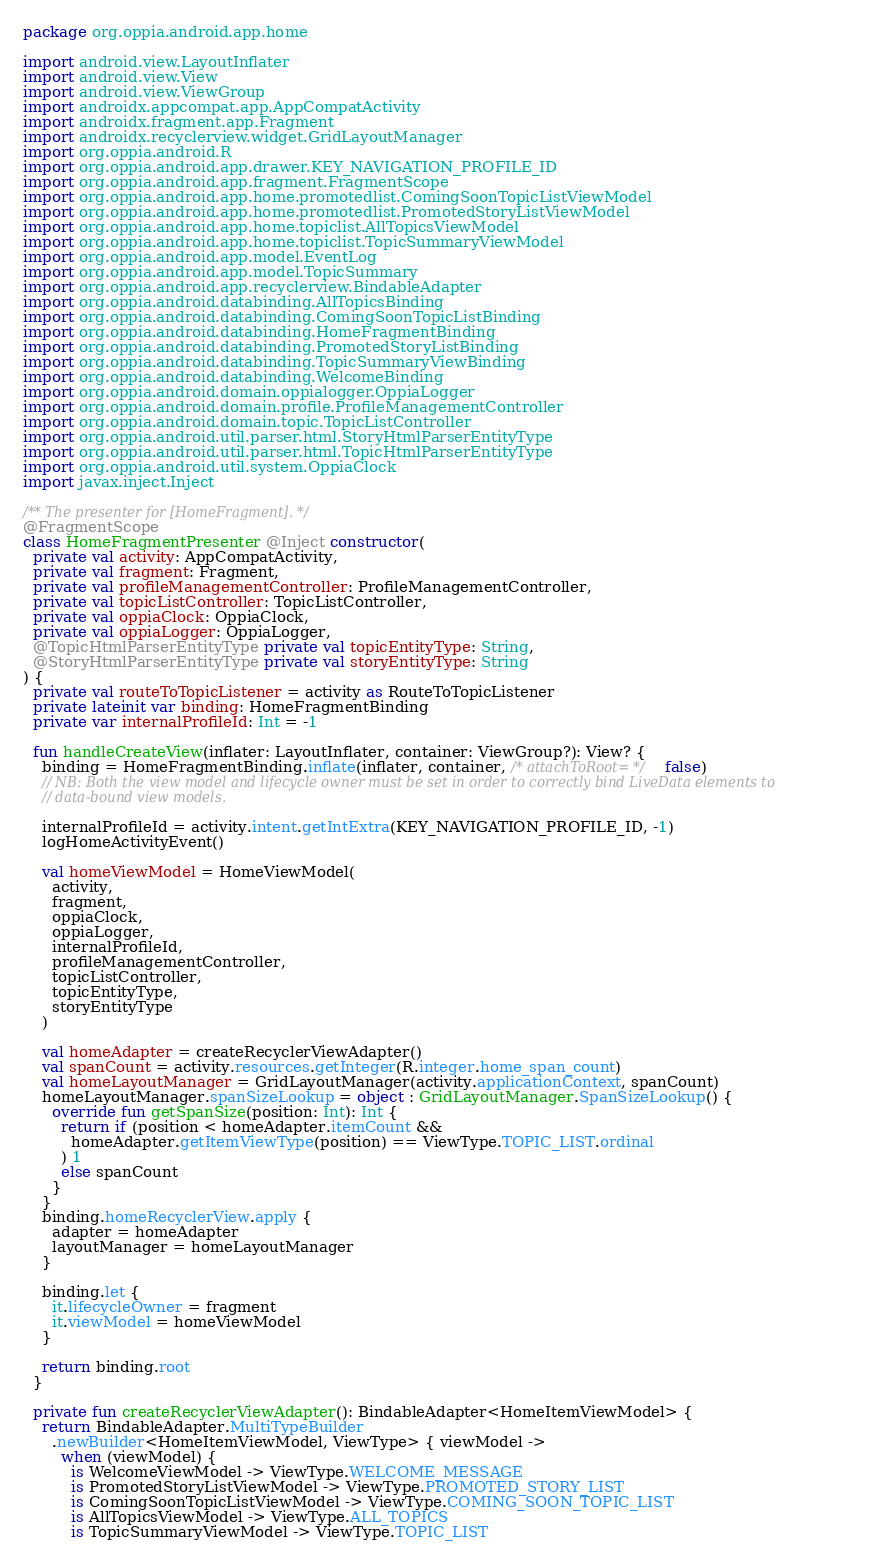Convert code to text. <code><loc_0><loc_0><loc_500><loc_500><_Kotlin_>package org.oppia.android.app.home

import android.view.LayoutInflater
import android.view.View
import android.view.ViewGroup
import androidx.appcompat.app.AppCompatActivity
import androidx.fragment.app.Fragment
import androidx.recyclerview.widget.GridLayoutManager
import org.oppia.android.R
import org.oppia.android.app.drawer.KEY_NAVIGATION_PROFILE_ID
import org.oppia.android.app.fragment.FragmentScope
import org.oppia.android.app.home.promotedlist.ComingSoonTopicListViewModel
import org.oppia.android.app.home.promotedlist.PromotedStoryListViewModel
import org.oppia.android.app.home.topiclist.AllTopicsViewModel
import org.oppia.android.app.home.topiclist.TopicSummaryViewModel
import org.oppia.android.app.model.EventLog
import org.oppia.android.app.model.TopicSummary
import org.oppia.android.app.recyclerview.BindableAdapter
import org.oppia.android.databinding.AllTopicsBinding
import org.oppia.android.databinding.ComingSoonTopicListBinding
import org.oppia.android.databinding.HomeFragmentBinding
import org.oppia.android.databinding.PromotedStoryListBinding
import org.oppia.android.databinding.TopicSummaryViewBinding
import org.oppia.android.databinding.WelcomeBinding
import org.oppia.android.domain.oppialogger.OppiaLogger
import org.oppia.android.domain.profile.ProfileManagementController
import org.oppia.android.domain.topic.TopicListController
import org.oppia.android.util.parser.html.StoryHtmlParserEntityType
import org.oppia.android.util.parser.html.TopicHtmlParserEntityType
import org.oppia.android.util.system.OppiaClock
import javax.inject.Inject

/** The presenter for [HomeFragment]. */
@FragmentScope
class HomeFragmentPresenter @Inject constructor(
  private val activity: AppCompatActivity,
  private val fragment: Fragment,
  private val profileManagementController: ProfileManagementController,
  private val topicListController: TopicListController,
  private val oppiaClock: OppiaClock,
  private val oppiaLogger: OppiaLogger,
  @TopicHtmlParserEntityType private val topicEntityType: String,
  @StoryHtmlParserEntityType private val storyEntityType: String
) {
  private val routeToTopicListener = activity as RouteToTopicListener
  private lateinit var binding: HomeFragmentBinding
  private var internalProfileId: Int = -1

  fun handleCreateView(inflater: LayoutInflater, container: ViewGroup?): View? {
    binding = HomeFragmentBinding.inflate(inflater, container, /* attachToRoot= */ false)
    // NB: Both the view model and lifecycle owner must be set in order to correctly bind LiveData elements to
    // data-bound view models.

    internalProfileId = activity.intent.getIntExtra(KEY_NAVIGATION_PROFILE_ID, -1)
    logHomeActivityEvent()

    val homeViewModel = HomeViewModel(
      activity,
      fragment,
      oppiaClock,
      oppiaLogger,
      internalProfileId,
      profileManagementController,
      topicListController,
      topicEntityType,
      storyEntityType
    )

    val homeAdapter = createRecyclerViewAdapter()
    val spanCount = activity.resources.getInteger(R.integer.home_span_count)
    val homeLayoutManager = GridLayoutManager(activity.applicationContext, spanCount)
    homeLayoutManager.spanSizeLookup = object : GridLayoutManager.SpanSizeLookup() {
      override fun getSpanSize(position: Int): Int {
        return if (position < homeAdapter.itemCount &&
          homeAdapter.getItemViewType(position) == ViewType.TOPIC_LIST.ordinal
        ) 1
        else spanCount
      }
    }
    binding.homeRecyclerView.apply {
      adapter = homeAdapter
      layoutManager = homeLayoutManager
    }

    binding.let {
      it.lifecycleOwner = fragment
      it.viewModel = homeViewModel
    }

    return binding.root
  }

  private fun createRecyclerViewAdapter(): BindableAdapter<HomeItemViewModel> {
    return BindableAdapter.MultiTypeBuilder
      .newBuilder<HomeItemViewModel, ViewType> { viewModel ->
        when (viewModel) {
          is WelcomeViewModel -> ViewType.WELCOME_MESSAGE
          is PromotedStoryListViewModel -> ViewType.PROMOTED_STORY_LIST
          is ComingSoonTopicListViewModel -> ViewType.COMING_SOON_TOPIC_LIST
          is AllTopicsViewModel -> ViewType.ALL_TOPICS
          is TopicSummaryViewModel -> ViewType.TOPIC_LIST</code> 